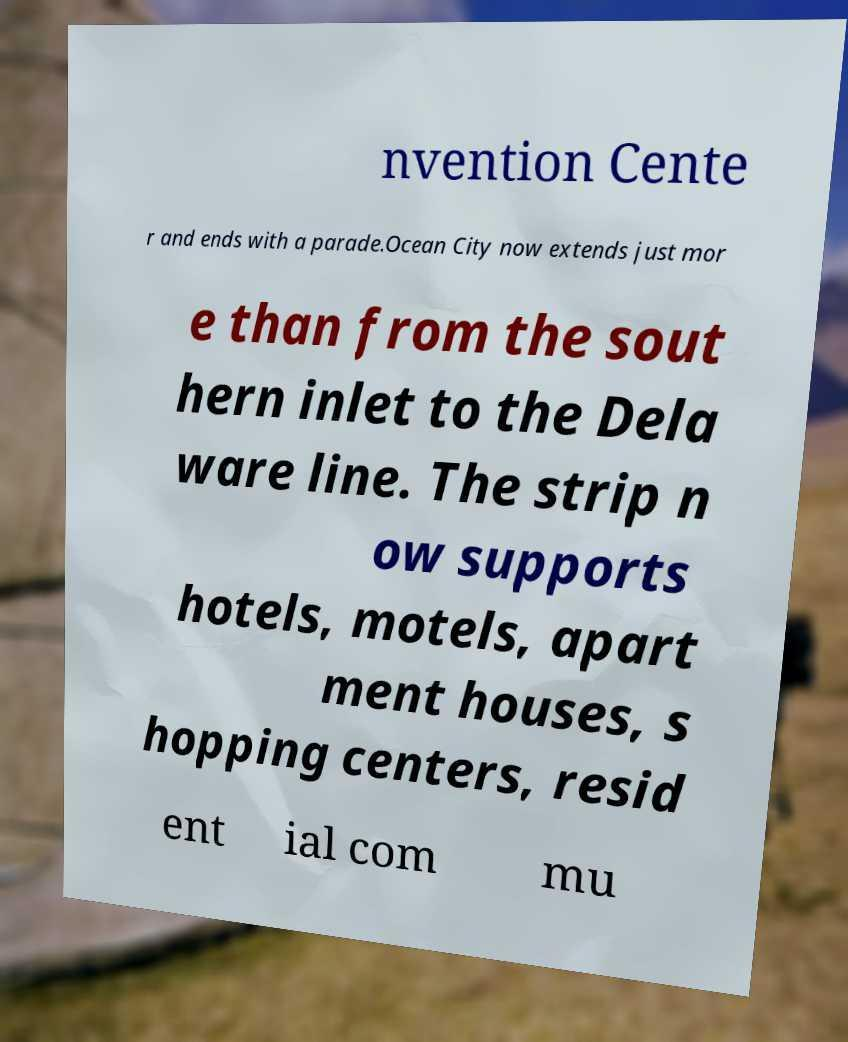Please identify and transcribe the text found in this image. nvention Cente r and ends with a parade.Ocean City now extends just mor e than from the sout hern inlet to the Dela ware line. The strip n ow supports hotels, motels, apart ment houses, s hopping centers, resid ent ial com mu 